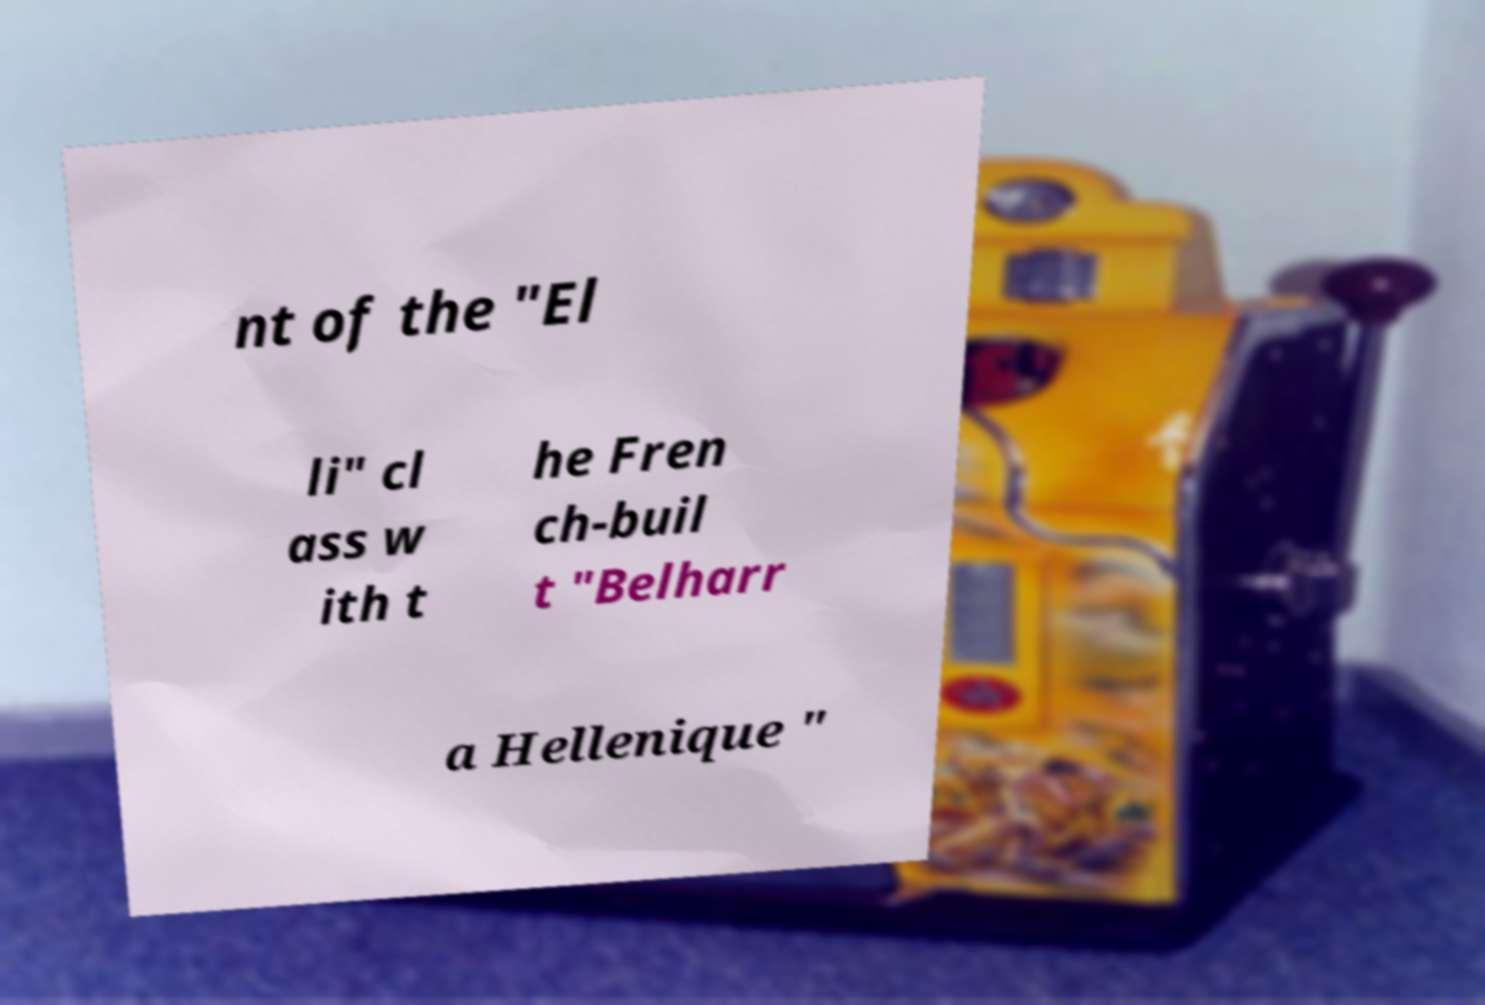Can you read and provide the text displayed in the image?This photo seems to have some interesting text. Can you extract and type it out for me? nt of the "El li" cl ass w ith t he Fren ch-buil t "Belharr a Hellenique " 